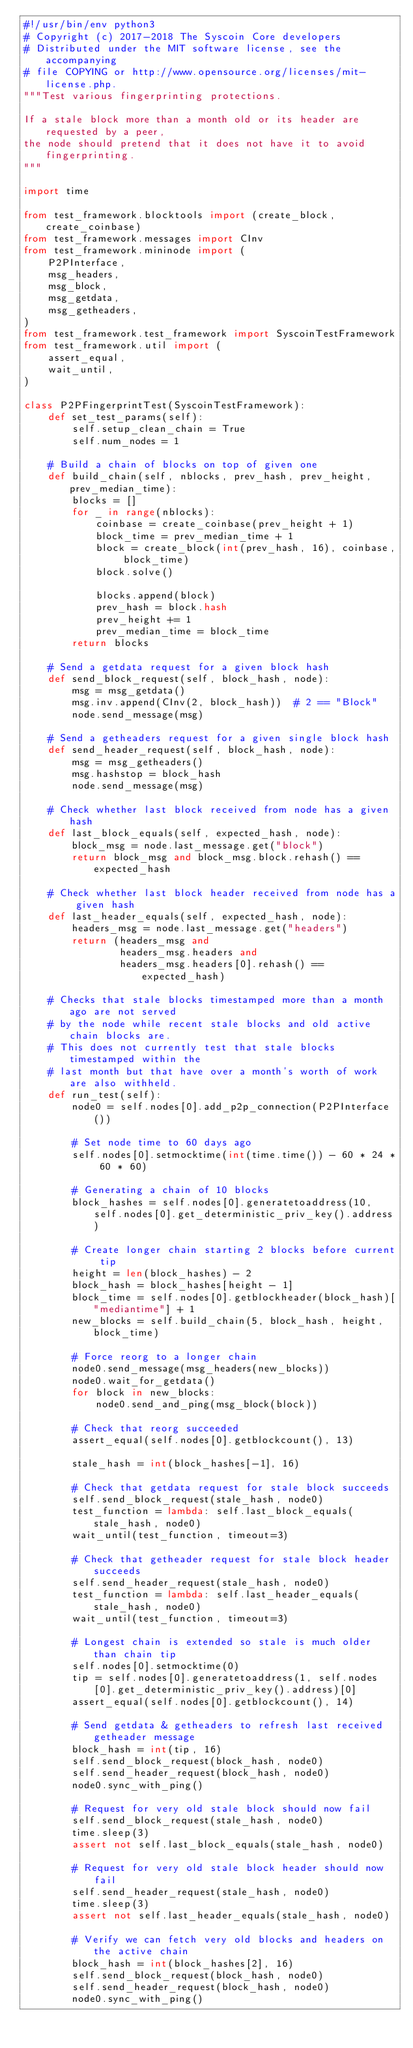<code> <loc_0><loc_0><loc_500><loc_500><_Python_>#!/usr/bin/env python3
# Copyright (c) 2017-2018 The Syscoin Core developers
# Distributed under the MIT software license, see the accompanying
# file COPYING or http://www.opensource.org/licenses/mit-license.php.
"""Test various fingerprinting protections.

If a stale block more than a month old or its header are requested by a peer,
the node should pretend that it does not have it to avoid fingerprinting.
"""

import time

from test_framework.blocktools import (create_block, create_coinbase)
from test_framework.messages import CInv
from test_framework.mininode import (
    P2PInterface,
    msg_headers,
    msg_block,
    msg_getdata,
    msg_getheaders,
)
from test_framework.test_framework import SyscoinTestFramework
from test_framework.util import (
    assert_equal,
    wait_until,
)

class P2PFingerprintTest(SyscoinTestFramework):
    def set_test_params(self):
        self.setup_clean_chain = True
        self.num_nodes = 1

    # Build a chain of blocks on top of given one
    def build_chain(self, nblocks, prev_hash, prev_height, prev_median_time):
        blocks = []
        for _ in range(nblocks):
            coinbase = create_coinbase(prev_height + 1)
            block_time = prev_median_time + 1
            block = create_block(int(prev_hash, 16), coinbase, block_time)
            block.solve()

            blocks.append(block)
            prev_hash = block.hash
            prev_height += 1
            prev_median_time = block_time
        return blocks

    # Send a getdata request for a given block hash
    def send_block_request(self, block_hash, node):
        msg = msg_getdata()
        msg.inv.append(CInv(2, block_hash))  # 2 == "Block"
        node.send_message(msg)

    # Send a getheaders request for a given single block hash
    def send_header_request(self, block_hash, node):
        msg = msg_getheaders()
        msg.hashstop = block_hash
        node.send_message(msg)

    # Check whether last block received from node has a given hash
    def last_block_equals(self, expected_hash, node):
        block_msg = node.last_message.get("block")
        return block_msg and block_msg.block.rehash() == expected_hash

    # Check whether last block header received from node has a given hash
    def last_header_equals(self, expected_hash, node):
        headers_msg = node.last_message.get("headers")
        return (headers_msg and
                headers_msg.headers and
                headers_msg.headers[0].rehash() == expected_hash)

    # Checks that stale blocks timestamped more than a month ago are not served
    # by the node while recent stale blocks and old active chain blocks are.
    # This does not currently test that stale blocks timestamped within the
    # last month but that have over a month's worth of work are also withheld.
    def run_test(self):
        node0 = self.nodes[0].add_p2p_connection(P2PInterface())

        # Set node time to 60 days ago
        self.nodes[0].setmocktime(int(time.time()) - 60 * 24 * 60 * 60)

        # Generating a chain of 10 blocks
        block_hashes = self.nodes[0].generatetoaddress(10, self.nodes[0].get_deterministic_priv_key().address)

        # Create longer chain starting 2 blocks before current tip
        height = len(block_hashes) - 2
        block_hash = block_hashes[height - 1]
        block_time = self.nodes[0].getblockheader(block_hash)["mediantime"] + 1
        new_blocks = self.build_chain(5, block_hash, height, block_time)

        # Force reorg to a longer chain
        node0.send_message(msg_headers(new_blocks))
        node0.wait_for_getdata()
        for block in new_blocks:
            node0.send_and_ping(msg_block(block))

        # Check that reorg succeeded
        assert_equal(self.nodes[0].getblockcount(), 13)

        stale_hash = int(block_hashes[-1], 16)

        # Check that getdata request for stale block succeeds
        self.send_block_request(stale_hash, node0)
        test_function = lambda: self.last_block_equals(stale_hash, node0)
        wait_until(test_function, timeout=3)

        # Check that getheader request for stale block header succeeds
        self.send_header_request(stale_hash, node0)
        test_function = lambda: self.last_header_equals(stale_hash, node0)
        wait_until(test_function, timeout=3)

        # Longest chain is extended so stale is much older than chain tip
        self.nodes[0].setmocktime(0)
        tip = self.nodes[0].generatetoaddress(1, self.nodes[0].get_deterministic_priv_key().address)[0]
        assert_equal(self.nodes[0].getblockcount(), 14)

        # Send getdata & getheaders to refresh last received getheader message
        block_hash = int(tip, 16)
        self.send_block_request(block_hash, node0)
        self.send_header_request(block_hash, node0)
        node0.sync_with_ping()

        # Request for very old stale block should now fail
        self.send_block_request(stale_hash, node0)
        time.sleep(3)
        assert not self.last_block_equals(stale_hash, node0)

        # Request for very old stale block header should now fail
        self.send_header_request(stale_hash, node0)
        time.sleep(3)
        assert not self.last_header_equals(stale_hash, node0)

        # Verify we can fetch very old blocks and headers on the active chain
        block_hash = int(block_hashes[2], 16)
        self.send_block_request(block_hash, node0)
        self.send_header_request(block_hash, node0)
        node0.sync_with_ping()
</code> 